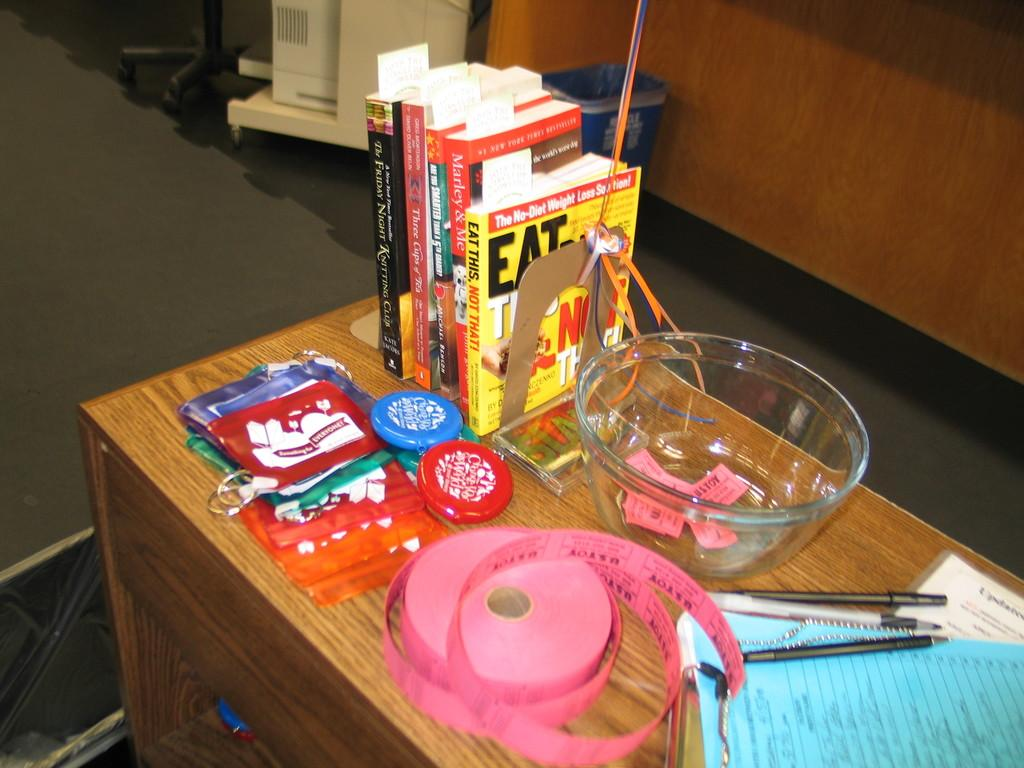<image>
Relay a brief, clear account of the picture shown. A yellow book with the word eat on it in black lettering is on a desk with other objects. 